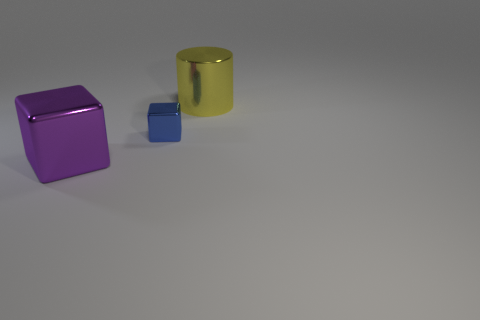What materials do the objects in the image seem to be made of? The objects in the image appear to have different materials. The small and large cubes seem to have a matte surface, suggesting they could be made of a solid material like plastic or painted wood, while the cylindrical object has a reflective surface that could indicate a metallic material. 